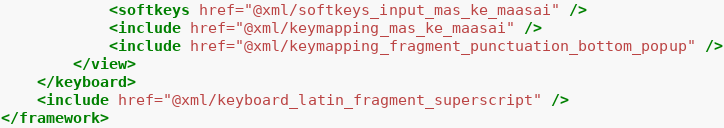Convert code to text. <code><loc_0><loc_0><loc_500><loc_500><_XML_>            <softkeys href="@xml/softkeys_input_mas_ke_maasai" />
            <include href="@xml/keymapping_mas_ke_maasai" />
            <include href="@xml/keymapping_fragment_punctuation_bottom_popup" />
        </view>
    </keyboard>
    <include href="@xml/keyboard_latin_fragment_superscript" />
</framework></code> 